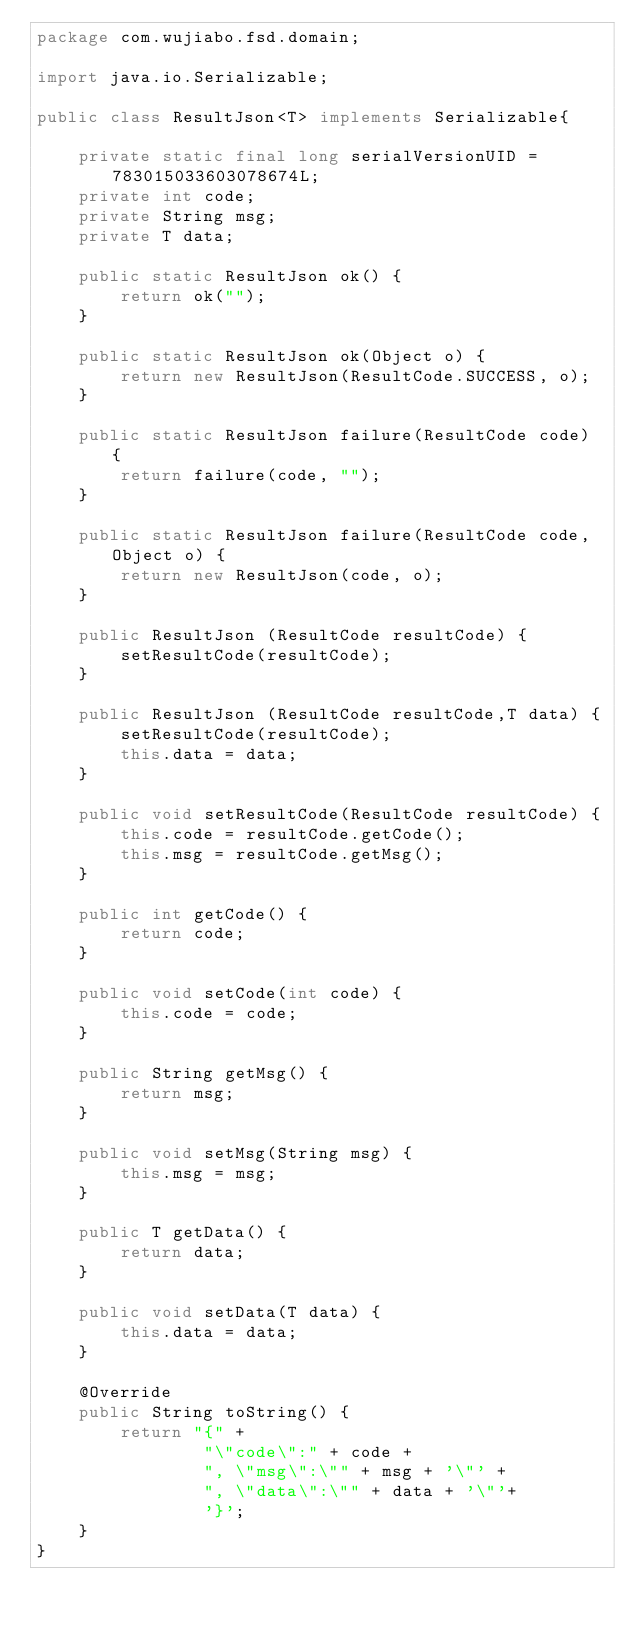<code> <loc_0><loc_0><loc_500><loc_500><_Java_>package com.wujiabo.fsd.domain;

import java.io.Serializable;

public class ResultJson<T> implements Serializable{

    private static final long serialVersionUID = 783015033603078674L;
    private int code;
    private String msg;
    private T data;

    public static ResultJson ok() {
        return ok("");
    }

    public static ResultJson ok(Object o) {
        return new ResultJson(ResultCode.SUCCESS, o);
    }

    public static ResultJson failure(ResultCode code) {
        return failure(code, "");
    }

    public static ResultJson failure(ResultCode code, Object o) {
        return new ResultJson(code, o);
    }

    public ResultJson (ResultCode resultCode) {
        setResultCode(resultCode);
    }

    public ResultJson (ResultCode resultCode,T data) {
        setResultCode(resultCode);
        this.data = data;
    }

    public void setResultCode(ResultCode resultCode) {
        this.code = resultCode.getCode();
        this.msg = resultCode.getMsg();
    }

    public int getCode() {
        return code;
    }

    public void setCode(int code) {
        this.code = code;
    }

    public String getMsg() {
        return msg;
    }

    public void setMsg(String msg) {
        this.msg = msg;
    }

    public T getData() {
        return data;
    }

    public void setData(T data) {
        this.data = data;
    }

    @Override
    public String toString() {
        return "{" +
                "\"code\":" + code +
                ", \"msg\":\"" + msg + '\"' +
                ", \"data\":\"" + data + '\"'+
                '}';
    }
}
</code> 